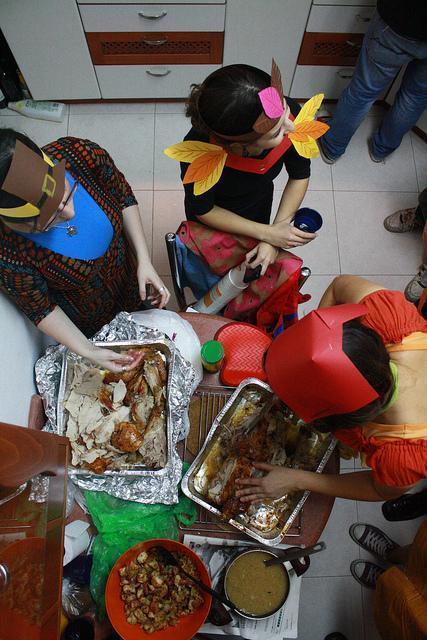What holiday do the people seem to be celebrating?
Pick the right solution, then justify: 'Answer: answer
Rationale: rationale.'
Options: Labor day, christmas, easter, thanksgiving. Answer: thanksgiving.
Rationale: Thanksgiving is a holiday that's all about food and turkey. 